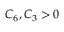<formula> <loc_0><loc_0><loc_500><loc_500>C _ { 6 } , C _ { 3 } > 0</formula> 